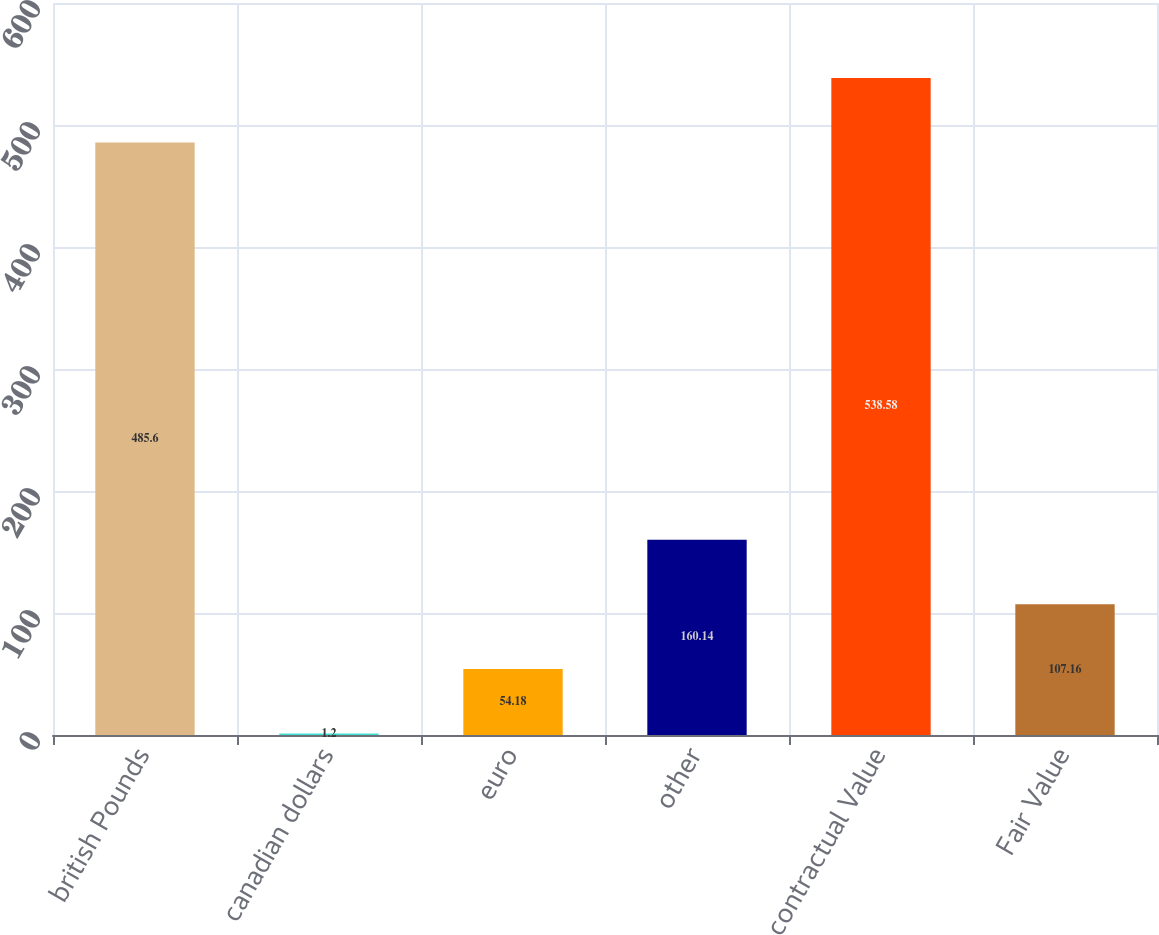<chart> <loc_0><loc_0><loc_500><loc_500><bar_chart><fcel>british Pounds<fcel>canadian dollars<fcel>euro<fcel>other<fcel>contractual Value<fcel>Fair Value<nl><fcel>485.6<fcel>1.2<fcel>54.18<fcel>160.14<fcel>538.58<fcel>107.16<nl></chart> 